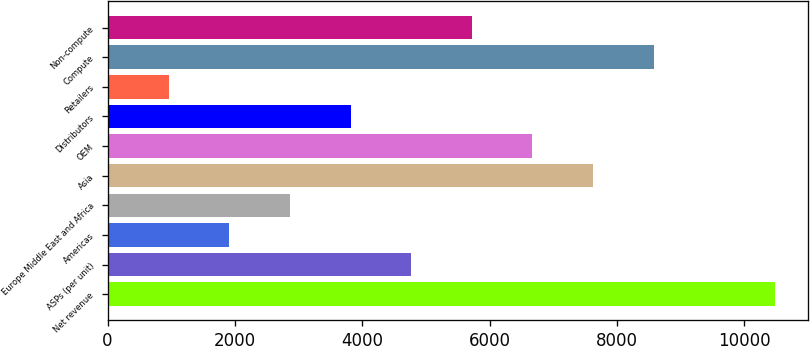Convert chart to OTSL. <chart><loc_0><loc_0><loc_500><loc_500><bar_chart><fcel>Net revenue<fcel>ASPs (per unit)<fcel>Americas<fcel>Europe Middle East and Africa<fcel>Asia<fcel>OEM<fcel>Distributors<fcel>Retailers<fcel>Compute<fcel>Non-compute<nl><fcel>10477.6<fcel>4768<fcel>1913.2<fcel>2864.8<fcel>7622.8<fcel>6671.2<fcel>3816.4<fcel>961.6<fcel>8574.4<fcel>5719.6<nl></chart> 